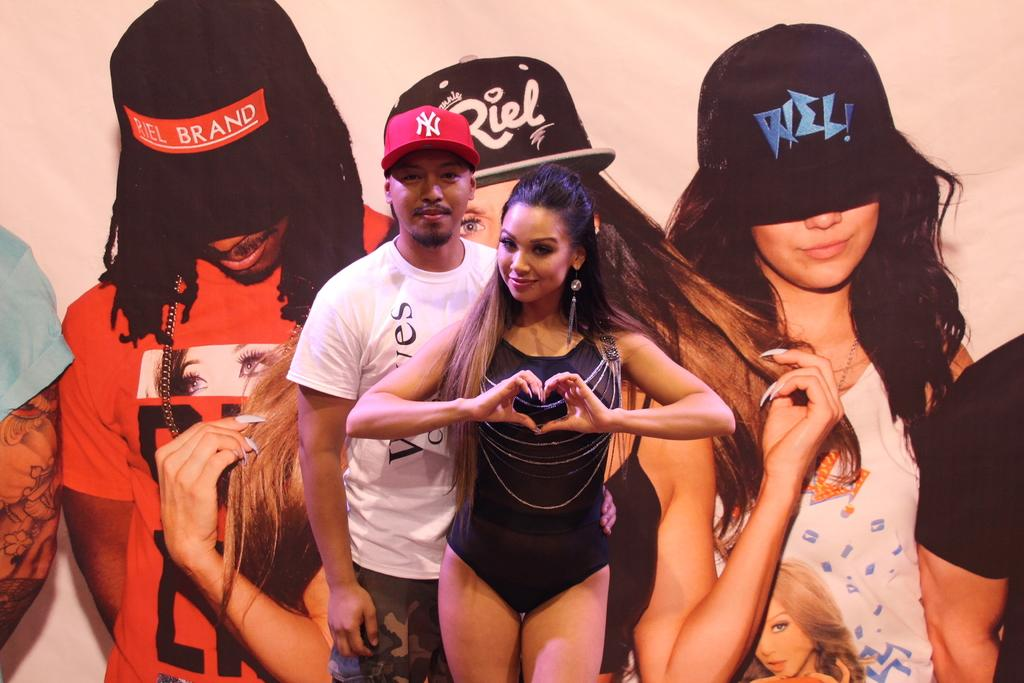<image>
Give a short and clear explanation of the subsequent image. A woman in a swimsuit and a man in a white shirt and a new york red hat are standing in front of a large billboard. 